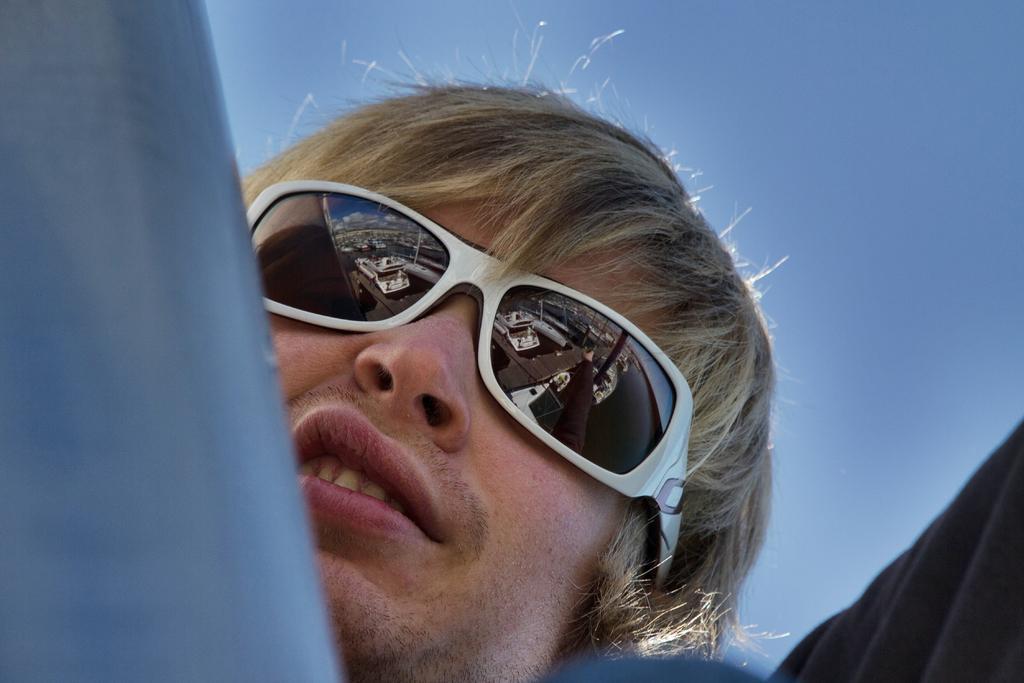In one or two sentences, can you explain what this image depicts? In front of the image there are some objects. Behind the objects there is a person. In the background of the image there is sky. 